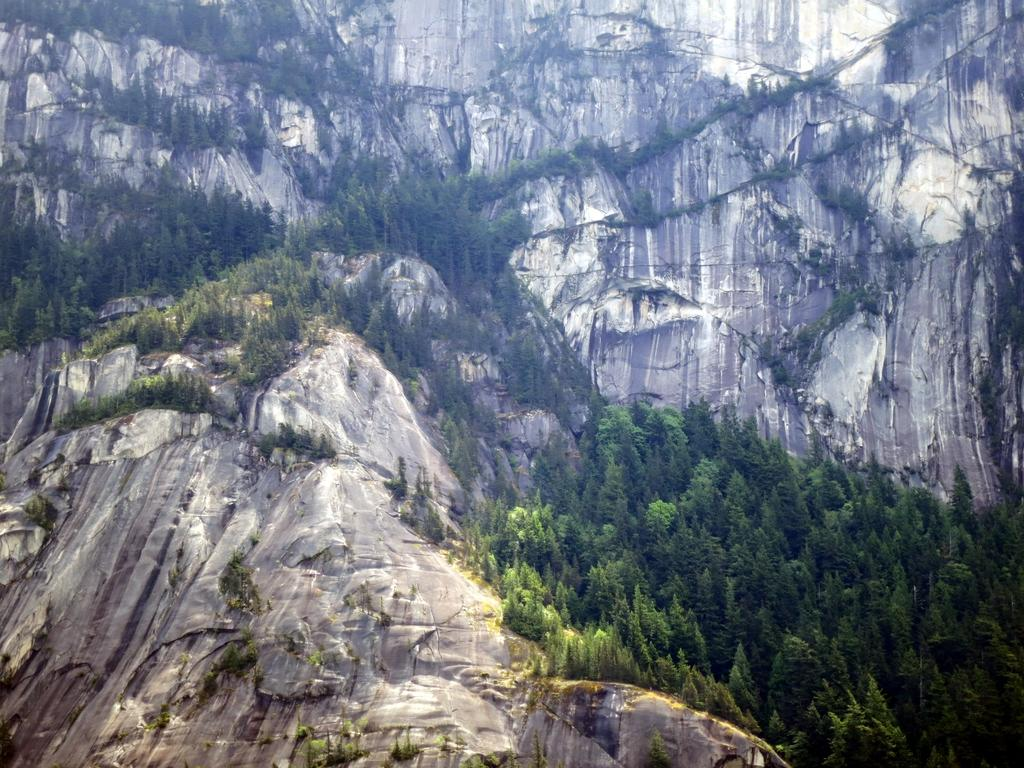What type of geographical feature is present in the image? There is a rocky mountain in the image. What type of vegetation can be seen in the image? There are trees in the image. Can you see a frog jumping on the rocky mountain in the image? There is no frog present in the image, and therefore no such activity can be observed. 